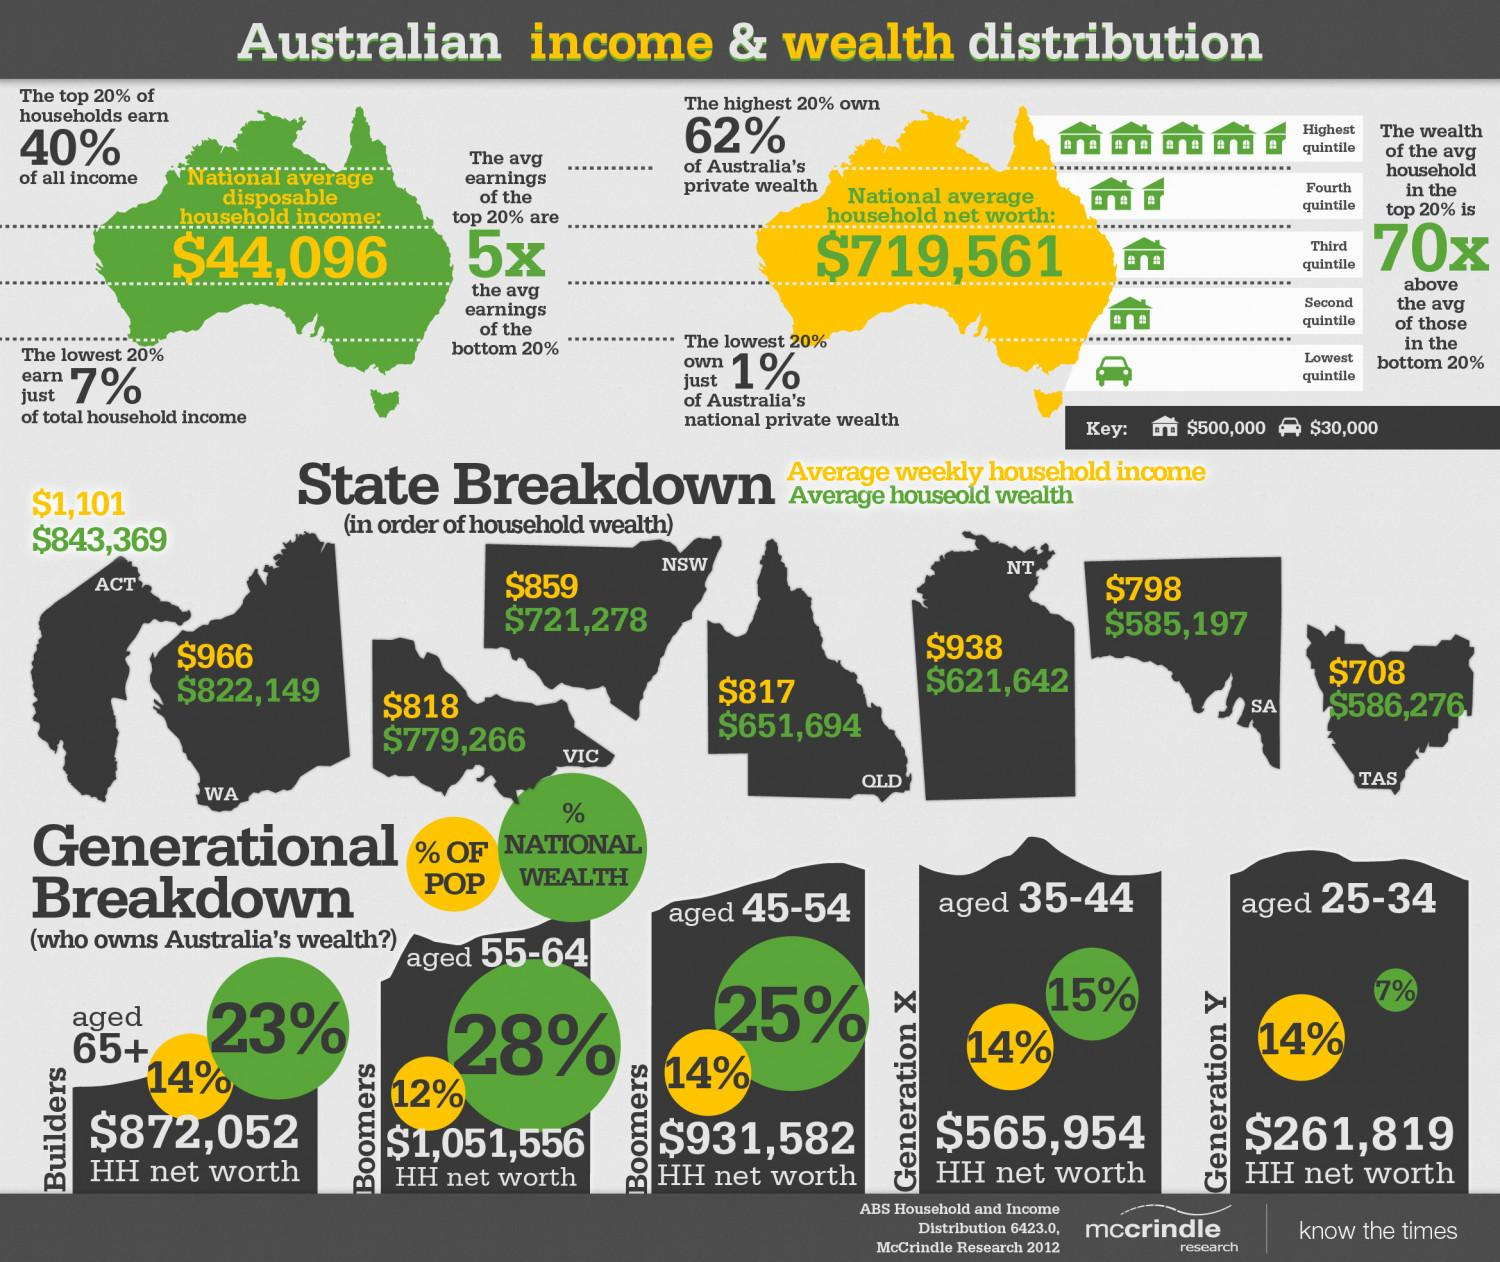Specify some key components in this picture. Generation X accounts for 15% of the national wealth. The percentage of POP of Builders is 14%. The net percentage of national wealth of Baby Boomers aged 45-64 is 53%. The net worth of individuals aged 25-44 is 827,773 according to HH data. The net worth of Builders is $872,052 as of today. 